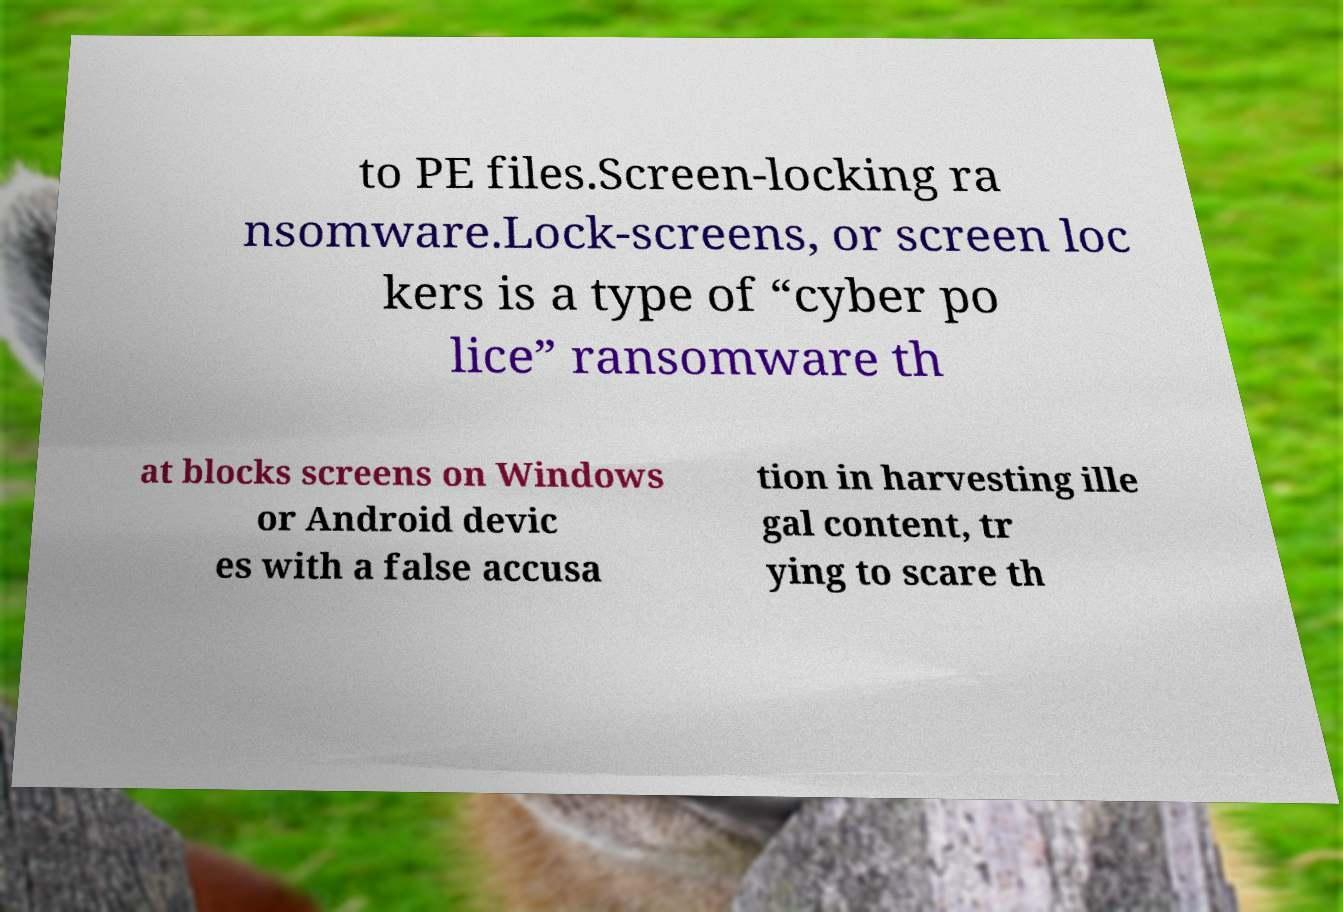There's text embedded in this image that I need extracted. Can you transcribe it verbatim? to PE files.Screen-locking ra nsomware.Lock-screens, or screen loc kers is a type of “cyber po lice” ransomware th at blocks screens on Windows or Android devic es with a false accusa tion in harvesting ille gal content, tr ying to scare th 